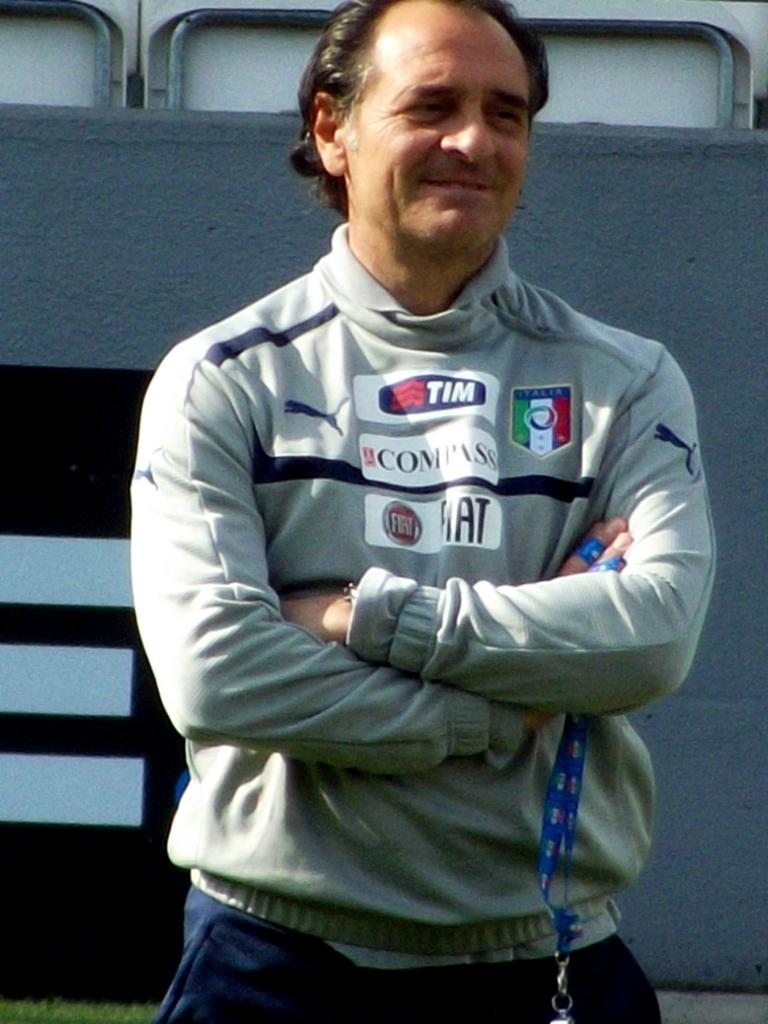Provide a one-sentence caption for the provided image. A man stands with his arms folded wearing a grey sweater that has stickers that say Tim, Compass and Fiat on them. 